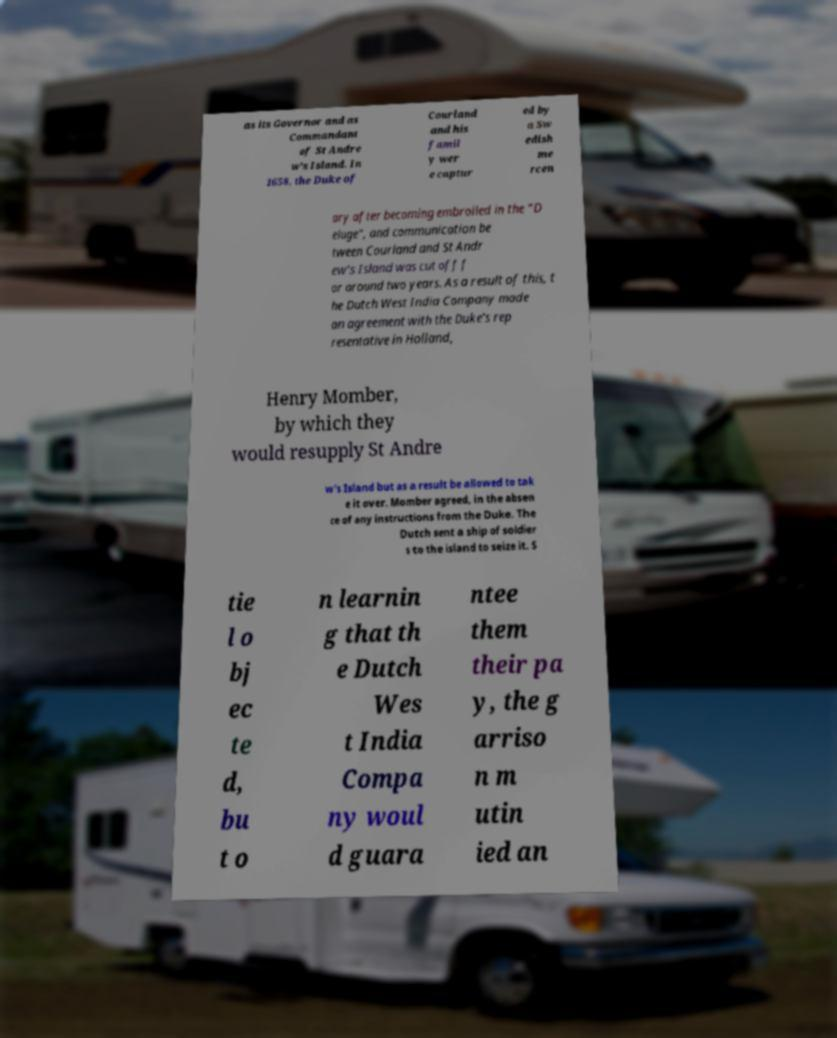Could you assist in decoding the text presented in this image and type it out clearly? as its Governor and as Commandant of St Andre w's Island. In 1658, the Duke of Courland and his famil y wer e captur ed by a Sw edish me rcen ary after becoming embroiled in the “D eluge”, and communication be tween Courland and St Andr ew's Island was cut off f or around two years. As a result of this, t he Dutch West India Company made an agreement with the Duke's rep resentative in Holland, Henry Momber, by which they would resupply St Andre w's Island but as a result be allowed to tak e it over. Momber agreed, in the absen ce of any instructions from the Duke. The Dutch sent a ship of soldier s to the island to seize it. S tie l o bj ec te d, bu t o n learnin g that th e Dutch Wes t India Compa ny woul d guara ntee them their pa y, the g arriso n m utin ied an 